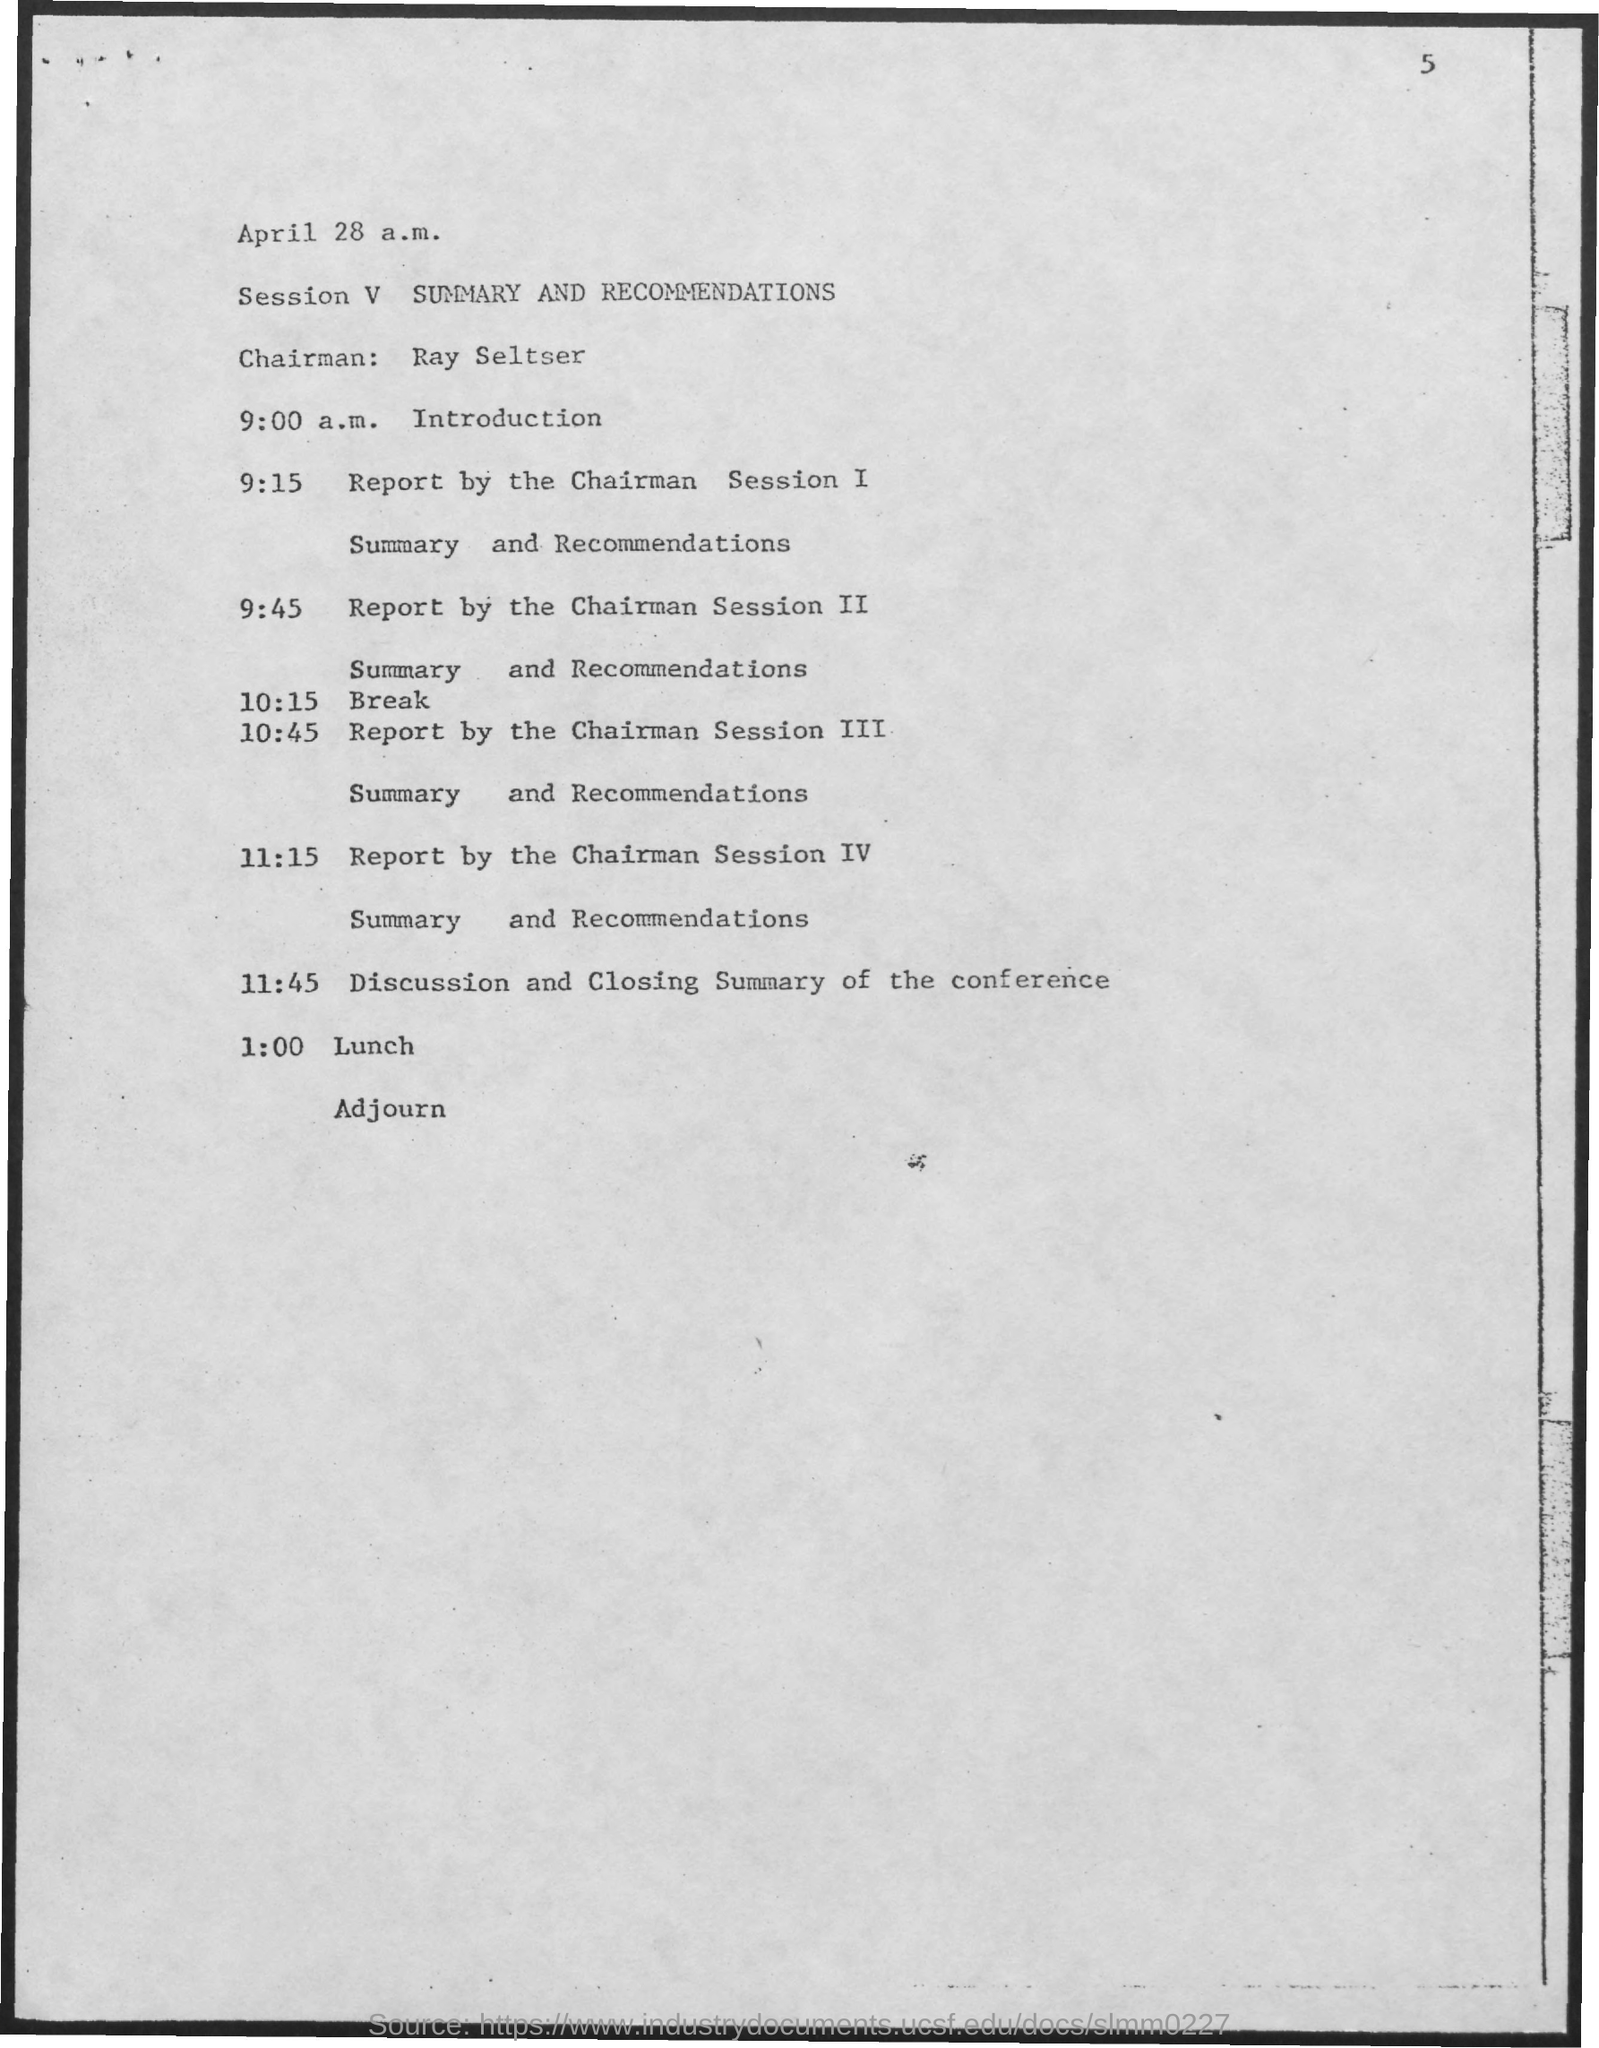What is session V about?
Your answer should be very brief. SUMMARY AND RECOMMENDATIONS. Who is the chairman?
Make the answer very short. Ray Seltser. What is the event at 11:45?
Provide a succinct answer. Discussion and Closing Summary of the conference. 